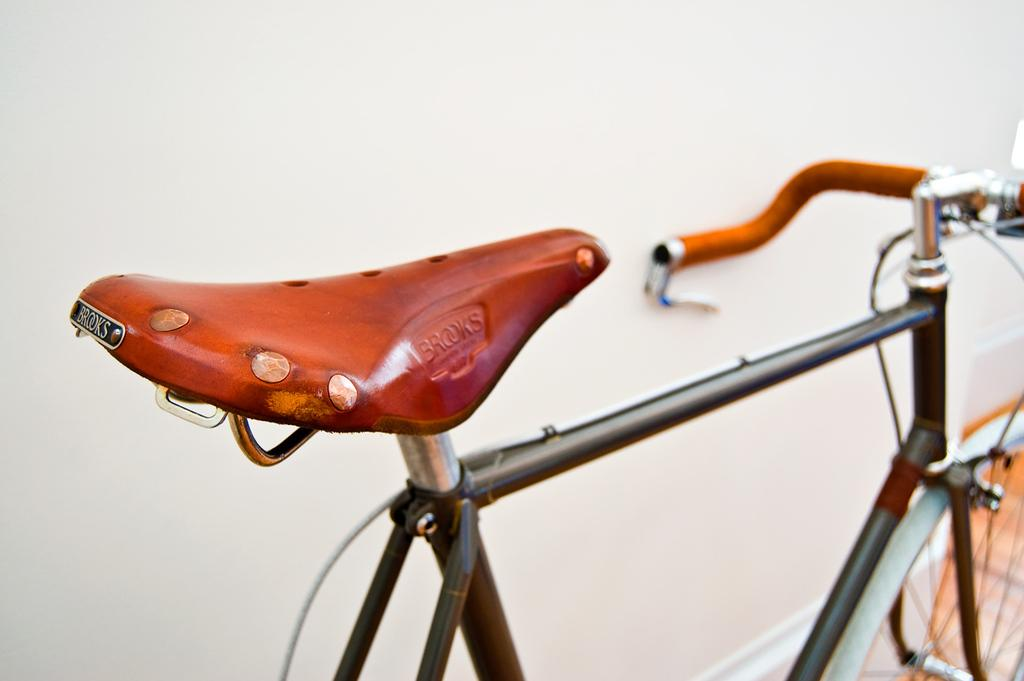What is the main object in the image? There is a bicycle in the image. What else can be seen in the image besides the bicycle? There is a wall in the image. Where is the doll's nose located in the image? There is no doll present in the image, so it is not possible to determine the location of its nose. 